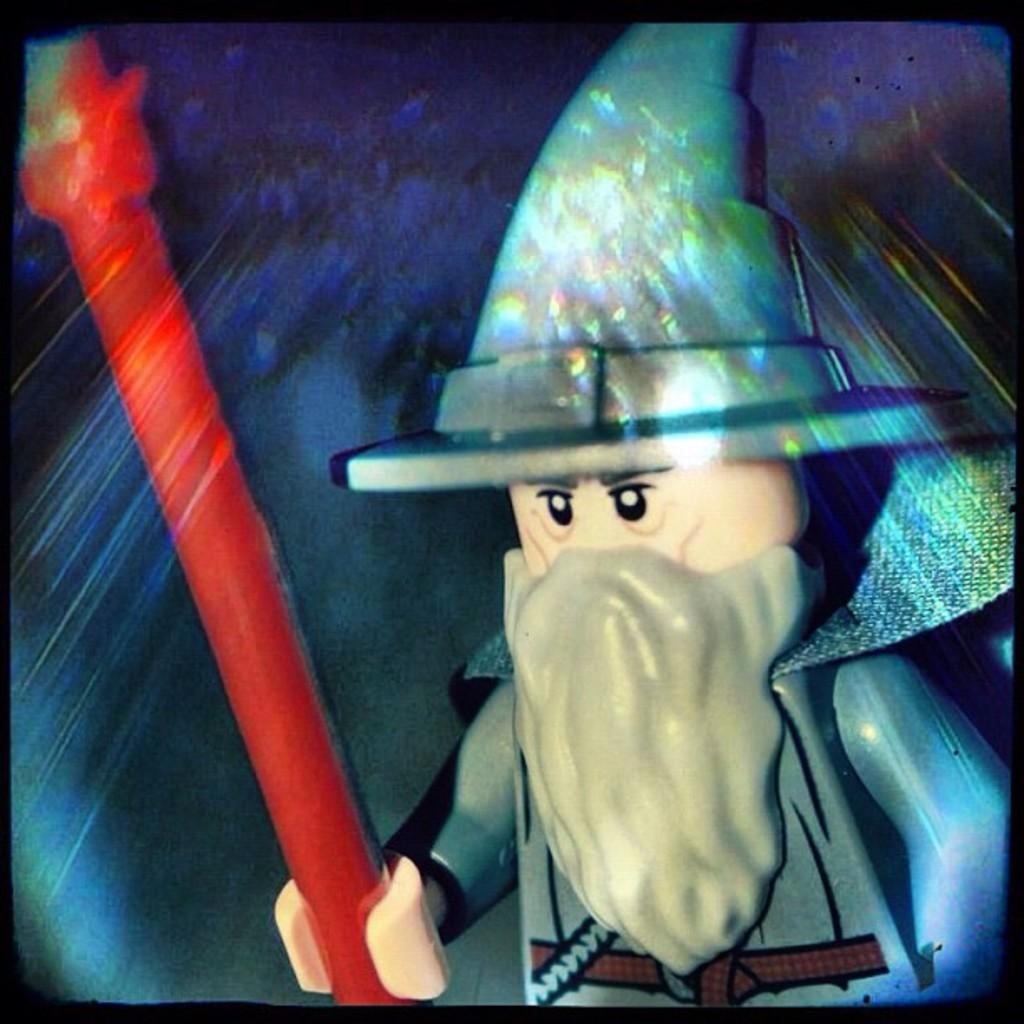What type of image is being described? The image is animated. Can you describe the main subject in the image? There is a person in the image. What is the person doing in the image? The person is holding an object. How many rings is the person wearing in the image? There are no rings visible on the person in the image. 